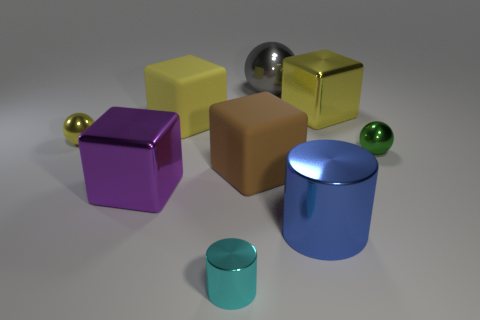What material is the large cylinder?
Ensure brevity in your answer.  Metal. Do the big yellow thing left of the tiny cyan cylinder and the tiny object in front of the large blue metal object have the same material?
Provide a short and direct response. No. Is there any other thing that has the same color as the tiny metal cylinder?
Ensure brevity in your answer.  No. There is a large metallic object that is the same shape as the small cyan thing; what color is it?
Ensure brevity in your answer.  Blue. What size is the metal thing that is both on the right side of the brown matte block and in front of the large brown matte object?
Provide a succinct answer. Large. There is a tiny shiny thing to the right of the blue metallic thing; is its shape the same as the large rubber object that is behind the small yellow ball?
Your response must be concise. No. How many small green balls have the same material as the big purple block?
Offer a very short reply. 1. There is a metallic object that is both right of the blue metal object and behind the green sphere; what is its shape?
Keep it short and to the point. Cube. Are the green thing that is to the right of the purple metallic cube and the large cylinder made of the same material?
Give a very brief answer. Yes. Is there any other thing that is the same material as the big purple block?
Offer a very short reply. Yes. 